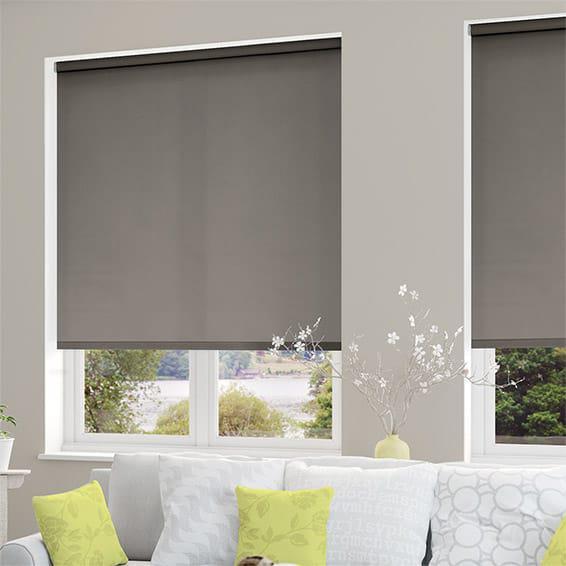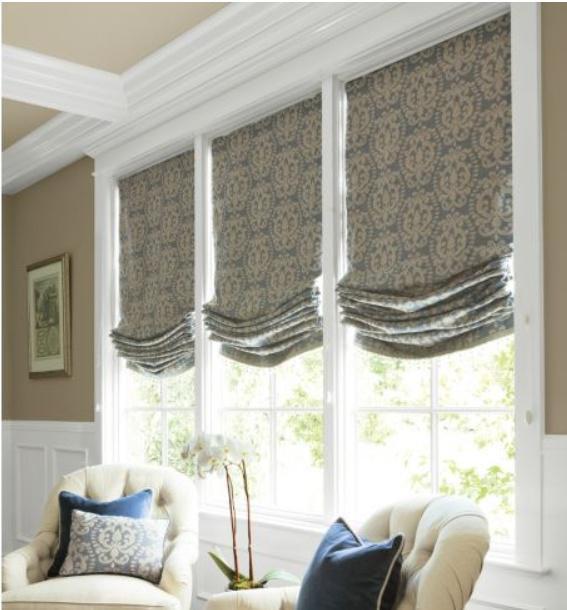The first image is the image on the left, the second image is the image on the right. For the images displayed, is the sentence "In at least one image there are three blinds behind at least two chairs." factually correct? Answer yes or no. Yes. The first image is the image on the left, the second image is the image on the right. For the images displayed, is the sentence "There are at least four window panes in one of the images." factually correct? Answer yes or no. No. 